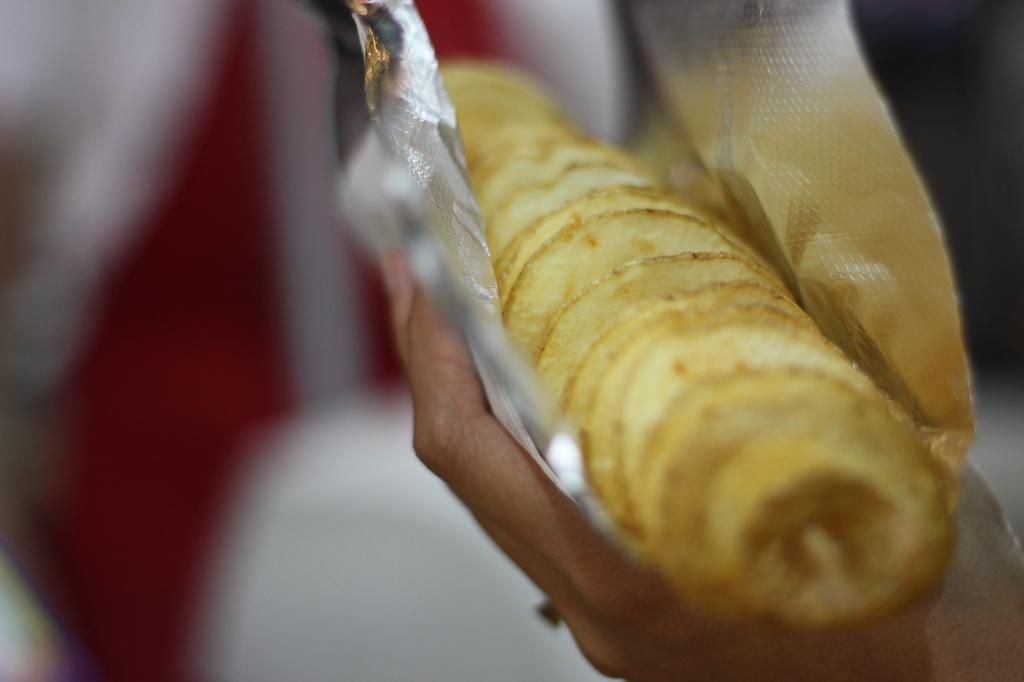What part of a person can be seen in the image? There is a person's hand in the image. What is the person holding in the image? The person is holding a food item in the wrapper. Can you describe the background of the image? The background of the image is blurred. What type of pancake is the person walking towards in the image? There is no pancake or person walking in the image; it only shows a person's hand holding a food item in the wrapper. 